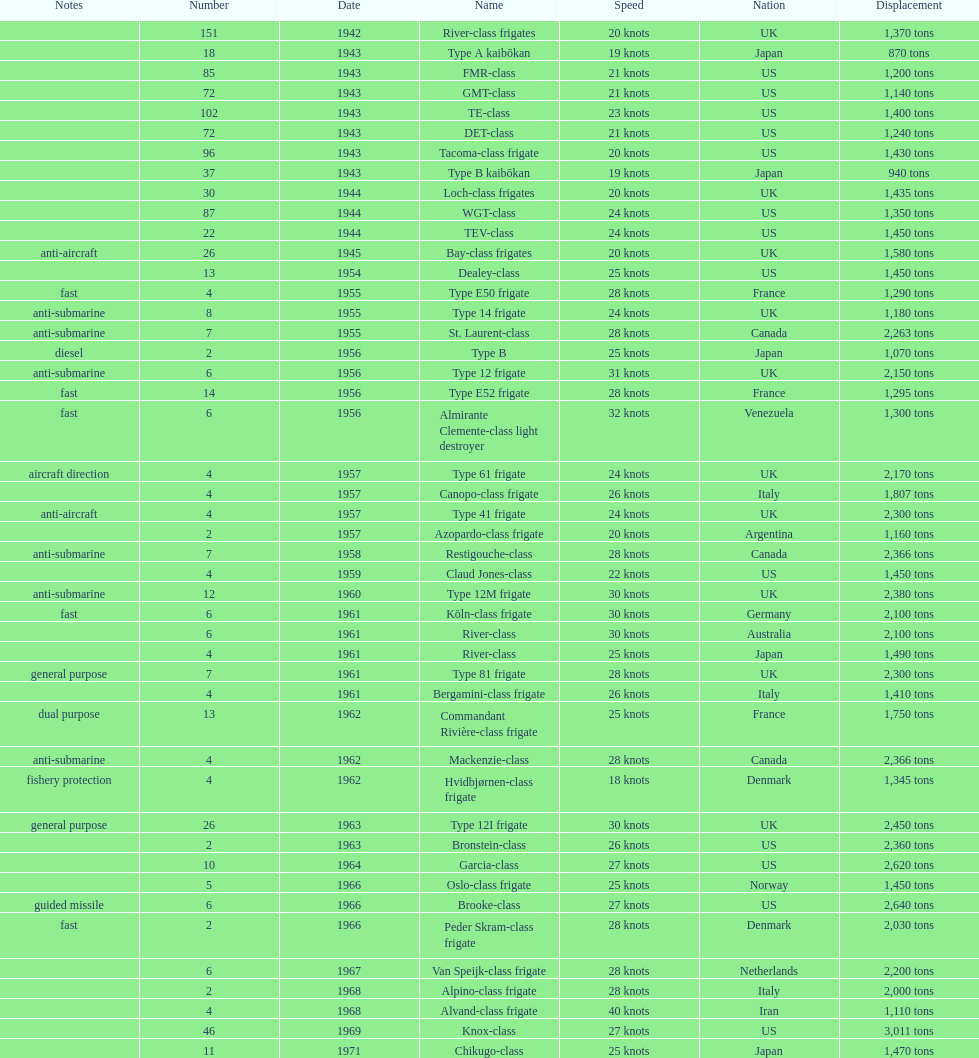How many consecutive escorts were in 1943? 7. 